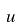Convert formula to latex. <formula><loc_0><loc_0><loc_500><loc_500>u</formula> 